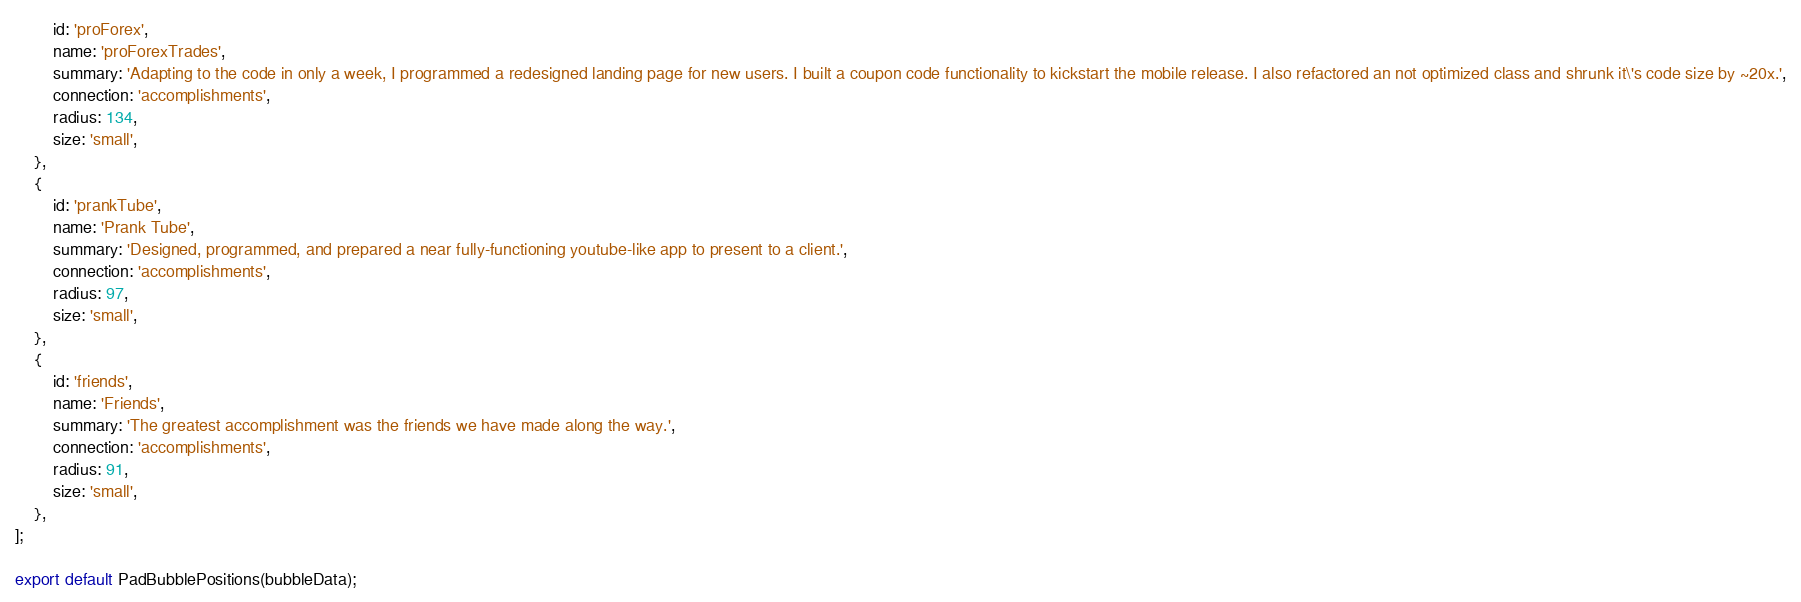<code> <loc_0><loc_0><loc_500><loc_500><_TypeScript_>		id: 'proForex',
		name: 'proForexTrades',
		summary: 'Adapting to the code in only a week, I programmed a redesigned landing page for new users. I built a coupon code functionality to kickstart the mobile release. I also refactored an not optimized class and shrunk it\'s code size by ~20x.',
		connection: 'accomplishments',
		radius: 134,
		size: 'small',
	},
	{
		id: 'prankTube',
		name: 'Prank Tube',
		summary: 'Designed, programmed, and prepared a near fully-functioning youtube-like app to present to a client.',
		connection: 'accomplishments',
		radius: 97,
		size: 'small',
	},
	{
		id: 'friends',
		name: 'Friends',
		summary: 'The greatest accomplishment was the friends we have made along the way.',
		connection: 'accomplishments',
		radius: 91,
		size: 'small',
	},
];

export default PadBubblePositions(bubbleData);</code> 